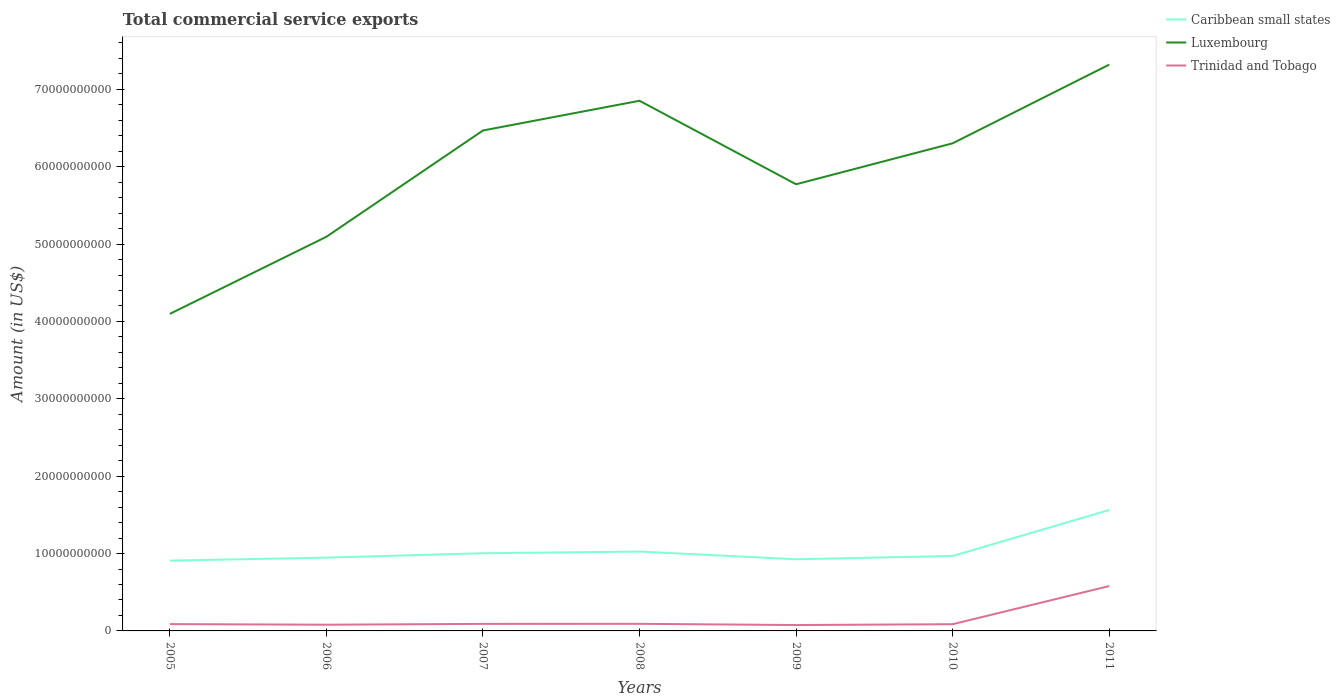How many different coloured lines are there?
Ensure brevity in your answer.  3. Is the number of lines equal to the number of legend labels?
Provide a succinct answer. Yes. Across all years, what is the maximum total commercial service exports in Luxembourg?
Your answer should be very brief. 4.10e+1. What is the total total commercial service exports in Luxembourg in the graph?
Give a very brief answer. -1.68e+1. What is the difference between the highest and the second highest total commercial service exports in Caribbean small states?
Your answer should be very brief. 6.55e+09. What is the difference between the highest and the lowest total commercial service exports in Luxembourg?
Your response must be concise. 4. How many lines are there?
Your answer should be very brief. 3. What is the difference between two consecutive major ticks on the Y-axis?
Provide a short and direct response. 1.00e+1. Are the values on the major ticks of Y-axis written in scientific E-notation?
Offer a terse response. No. How many legend labels are there?
Keep it short and to the point. 3. What is the title of the graph?
Keep it short and to the point. Total commercial service exports. What is the label or title of the X-axis?
Make the answer very short. Years. What is the label or title of the Y-axis?
Your answer should be compact. Amount (in US$). What is the Amount (in US$) in Caribbean small states in 2005?
Keep it short and to the point. 9.09e+09. What is the Amount (in US$) in Luxembourg in 2005?
Your response must be concise. 4.10e+1. What is the Amount (in US$) in Trinidad and Tobago in 2005?
Offer a terse response. 8.83e+08. What is the Amount (in US$) of Caribbean small states in 2006?
Make the answer very short. 9.47e+09. What is the Amount (in US$) of Luxembourg in 2006?
Give a very brief answer. 5.09e+1. What is the Amount (in US$) in Trinidad and Tobago in 2006?
Your answer should be compact. 8.02e+08. What is the Amount (in US$) in Caribbean small states in 2007?
Offer a terse response. 1.00e+1. What is the Amount (in US$) of Luxembourg in 2007?
Offer a very short reply. 6.47e+1. What is the Amount (in US$) of Trinidad and Tobago in 2007?
Make the answer very short. 9.10e+08. What is the Amount (in US$) of Caribbean small states in 2008?
Give a very brief answer. 1.03e+1. What is the Amount (in US$) in Luxembourg in 2008?
Provide a short and direct response. 6.85e+1. What is the Amount (in US$) in Trinidad and Tobago in 2008?
Offer a very short reply. 9.18e+08. What is the Amount (in US$) of Caribbean small states in 2009?
Offer a terse response. 9.26e+09. What is the Amount (in US$) of Luxembourg in 2009?
Provide a succinct answer. 5.77e+1. What is the Amount (in US$) in Trinidad and Tobago in 2009?
Your response must be concise. 7.58e+08. What is the Amount (in US$) of Caribbean small states in 2010?
Give a very brief answer. 9.69e+09. What is the Amount (in US$) in Luxembourg in 2010?
Ensure brevity in your answer.  6.30e+1. What is the Amount (in US$) in Trinidad and Tobago in 2010?
Give a very brief answer. 8.69e+08. What is the Amount (in US$) in Caribbean small states in 2011?
Provide a succinct answer. 1.56e+1. What is the Amount (in US$) in Luxembourg in 2011?
Offer a terse response. 7.32e+1. What is the Amount (in US$) of Trinidad and Tobago in 2011?
Your response must be concise. 5.80e+09. Across all years, what is the maximum Amount (in US$) in Caribbean small states?
Your answer should be very brief. 1.56e+1. Across all years, what is the maximum Amount (in US$) in Luxembourg?
Provide a short and direct response. 7.32e+1. Across all years, what is the maximum Amount (in US$) of Trinidad and Tobago?
Your response must be concise. 5.80e+09. Across all years, what is the minimum Amount (in US$) of Caribbean small states?
Provide a succinct answer. 9.09e+09. Across all years, what is the minimum Amount (in US$) of Luxembourg?
Your answer should be compact. 4.10e+1. Across all years, what is the minimum Amount (in US$) of Trinidad and Tobago?
Your response must be concise. 7.58e+08. What is the total Amount (in US$) in Caribbean small states in the graph?
Your answer should be very brief. 7.34e+1. What is the total Amount (in US$) in Luxembourg in the graph?
Your response must be concise. 4.19e+11. What is the total Amount (in US$) of Trinidad and Tobago in the graph?
Ensure brevity in your answer.  1.09e+1. What is the difference between the Amount (in US$) in Caribbean small states in 2005 and that in 2006?
Make the answer very short. -3.86e+08. What is the difference between the Amount (in US$) of Luxembourg in 2005 and that in 2006?
Provide a short and direct response. -9.97e+09. What is the difference between the Amount (in US$) of Trinidad and Tobago in 2005 and that in 2006?
Offer a terse response. 8.14e+07. What is the difference between the Amount (in US$) in Caribbean small states in 2005 and that in 2007?
Give a very brief answer. -9.54e+08. What is the difference between the Amount (in US$) of Luxembourg in 2005 and that in 2007?
Offer a very short reply. -2.37e+1. What is the difference between the Amount (in US$) in Trinidad and Tobago in 2005 and that in 2007?
Provide a succinct answer. -2.70e+07. What is the difference between the Amount (in US$) in Caribbean small states in 2005 and that in 2008?
Your response must be concise. -1.17e+09. What is the difference between the Amount (in US$) of Luxembourg in 2005 and that in 2008?
Give a very brief answer. -2.75e+1. What is the difference between the Amount (in US$) in Trinidad and Tobago in 2005 and that in 2008?
Provide a short and direct response. -3.54e+07. What is the difference between the Amount (in US$) in Caribbean small states in 2005 and that in 2009?
Make the answer very short. -1.77e+08. What is the difference between the Amount (in US$) in Luxembourg in 2005 and that in 2009?
Offer a very short reply. -1.68e+1. What is the difference between the Amount (in US$) in Trinidad and Tobago in 2005 and that in 2009?
Make the answer very short. 1.24e+08. What is the difference between the Amount (in US$) of Caribbean small states in 2005 and that in 2010?
Ensure brevity in your answer.  -6.00e+08. What is the difference between the Amount (in US$) in Luxembourg in 2005 and that in 2010?
Offer a very short reply. -2.20e+1. What is the difference between the Amount (in US$) of Trinidad and Tobago in 2005 and that in 2010?
Your response must be concise. 1.41e+07. What is the difference between the Amount (in US$) of Caribbean small states in 2005 and that in 2011?
Provide a succinct answer. -6.55e+09. What is the difference between the Amount (in US$) in Luxembourg in 2005 and that in 2011?
Ensure brevity in your answer.  -3.22e+1. What is the difference between the Amount (in US$) of Trinidad and Tobago in 2005 and that in 2011?
Your response must be concise. -4.92e+09. What is the difference between the Amount (in US$) of Caribbean small states in 2006 and that in 2007?
Your response must be concise. -5.68e+08. What is the difference between the Amount (in US$) of Luxembourg in 2006 and that in 2007?
Your answer should be very brief. -1.37e+1. What is the difference between the Amount (in US$) in Trinidad and Tobago in 2006 and that in 2007?
Provide a short and direct response. -1.08e+08. What is the difference between the Amount (in US$) of Caribbean small states in 2006 and that in 2008?
Provide a succinct answer. -7.85e+08. What is the difference between the Amount (in US$) in Luxembourg in 2006 and that in 2008?
Ensure brevity in your answer.  -1.76e+1. What is the difference between the Amount (in US$) of Trinidad and Tobago in 2006 and that in 2008?
Give a very brief answer. -1.17e+08. What is the difference between the Amount (in US$) in Caribbean small states in 2006 and that in 2009?
Keep it short and to the point. 2.09e+08. What is the difference between the Amount (in US$) of Luxembourg in 2006 and that in 2009?
Offer a very short reply. -6.79e+09. What is the difference between the Amount (in US$) of Trinidad and Tobago in 2006 and that in 2009?
Provide a succinct answer. 4.31e+07. What is the difference between the Amount (in US$) in Caribbean small states in 2006 and that in 2010?
Offer a terse response. -2.14e+08. What is the difference between the Amount (in US$) in Luxembourg in 2006 and that in 2010?
Provide a succinct answer. -1.21e+1. What is the difference between the Amount (in US$) in Trinidad and Tobago in 2006 and that in 2010?
Provide a short and direct response. -6.73e+07. What is the difference between the Amount (in US$) of Caribbean small states in 2006 and that in 2011?
Give a very brief answer. -6.16e+09. What is the difference between the Amount (in US$) of Luxembourg in 2006 and that in 2011?
Keep it short and to the point. -2.23e+1. What is the difference between the Amount (in US$) in Trinidad and Tobago in 2006 and that in 2011?
Offer a terse response. -5.00e+09. What is the difference between the Amount (in US$) of Caribbean small states in 2007 and that in 2008?
Provide a short and direct response. -2.17e+08. What is the difference between the Amount (in US$) of Luxembourg in 2007 and that in 2008?
Give a very brief answer. -3.84e+09. What is the difference between the Amount (in US$) in Trinidad and Tobago in 2007 and that in 2008?
Make the answer very short. -8.40e+06. What is the difference between the Amount (in US$) in Caribbean small states in 2007 and that in 2009?
Your answer should be compact. 7.77e+08. What is the difference between the Amount (in US$) of Luxembourg in 2007 and that in 2009?
Provide a short and direct response. 6.95e+09. What is the difference between the Amount (in US$) of Trinidad and Tobago in 2007 and that in 2009?
Keep it short and to the point. 1.52e+08. What is the difference between the Amount (in US$) of Caribbean small states in 2007 and that in 2010?
Offer a terse response. 3.54e+08. What is the difference between the Amount (in US$) in Luxembourg in 2007 and that in 2010?
Your answer should be compact. 1.66e+09. What is the difference between the Amount (in US$) of Trinidad and Tobago in 2007 and that in 2010?
Offer a terse response. 4.11e+07. What is the difference between the Amount (in US$) of Caribbean small states in 2007 and that in 2011?
Offer a terse response. -5.60e+09. What is the difference between the Amount (in US$) in Luxembourg in 2007 and that in 2011?
Keep it short and to the point. -8.52e+09. What is the difference between the Amount (in US$) of Trinidad and Tobago in 2007 and that in 2011?
Offer a very short reply. -4.89e+09. What is the difference between the Amount (in US$) in Caribbean small states in 2008 and that in 2009?
Your response must be concise. 9.94e+08. What is the difference between the Amount (in US$) in Luxembourg in 2008 and that in 2009?
Offer a very short reply. 1.08e+1. What is the difference between the Amount (in US$) in Trinidad and Tobago in 2008 and that in 2009?
Keep it short and to the point. 1.60e+08. What is the difference between the Amount (in US$) of Caribbean small states in 2008 and that in 2010?
Offer a very short reply. 5.71e+08. What is the difference between the Amount (in US$) of Luxembourg in 2008 and that in 2010?
Offer a very short reply. 5.50e+09. What is the difference between the Amount (in US$) of Trinidad and Tobago in 2008 and that in 2010?
Offer a terse response. 4.95e+07. What is the difference between the Amount (in US$) of Caribbean small states in 2008 and that in 2011?
Provide a succinct answer. -5.38e+09. What is the difference between the Amount (in US$) of Luxembourg in 2008 and that in 2011?
Your answer should be compact. -4.67e+09. What is the difference between the Amount (in US$) in Trinidad and Tobago in 2008 and that in 2011?
Provide a succinct answer. -4.88e+09. What is the difference between the Amount (in US$) of Caribbean small states in 2009 and that in 2010?
Provide a short and direct response. -4.23e+08. What is the difference between the Amount (in US$) of Luxembourg in 2009 and that in 2010?
Ensure brevity in your answer.  -5.29e+09. What is the difference between the Amount (in US$) in Trinidad and Tobago in 2009 and that in 2010?
Keep it short and to the point. -1.10e+08. What is the difference between the Amount (in US$) of Caribbean small states in 2009 and that in 2011?
Keep it short and to the point. -6.37e+09. What is the difference between the Amount (in US$) in Luxembourg in 2009 and that in 2011?
Your response must be concise. -1.55e+1. What is the difference between the Amount (in US$) in Trinidad and Tobago in 2009 and that in 2011?
Give a very brief answer. -5.04e+09. What is the difference between the Amount (in US$) of Caribbean small states in 2010 and that in 2011?
Give a very brief answer. -5.95e+09. What is the difference between the Amount (in US$) of Luxembourg in 2010 and that in 2011?
Keep it short and to the point. -1.02e+1. What is the difference between the Amount (in US$) of Trinidad and Tobago in 2010 and that in 2011?
Your answer should be very brief. -4.93e+09. What is the difference between the Amount (in US$) in Caribbean small states in 2005 and the Amount (in US$) in Luxembourg in 2006?
Ensure brevity in your answer.  -4.19e+1. What is the difference between the Amount (in US$) of Caribbean small states in 2005 and the Amount (in US$) of Trinidad and Tobago in 2006?
Keep it short and to the point. 8.29e+09. What is the difference between the Amount (in US$) in Luxembourg in 2005 and the Amount (in US$) in Trinidad and Tobago in 2006?
Make the answer very short. 4.02e+1. What is the difference between the Amount (in US$) of Caribbean small states in 2005 and the Amount (in US$) of Luxembourg in 2007?
Your response must be concise. -5.56e+1. What is the difference between the Amount (in US$) of Caribbean small states in 2005 and the Amount (in US$) of Trinidad and Tobago in 2007?
Give a very brief answer. 8.18e+09. What is the difference between the Amount (in US$) of Luxembourg in 2005 and the Amount (in US$) of Trinidad and Tobago in 2007?
Your answer should be very brief. 4.01e+1. What is the difference between the Amount (in US$) in Caribbean small states in 2005 and the Amount (in US$) in Luxembourg in 2008?
Your answer should be very brief. -5.94e+1. What is the difference between the Amount (in US$) of Caribbean small states in 2005 and the Amount (in US$) of Trinidad and Tobago in 2008?
Your answer should be compact. 8.17e+09. What is the difference between the Amount (in US$) in Luxembourg in 2005 and the Amount (in US$) in Trinidad and Tobago in 2008?
Your answer should be compact. 4.01e+1. What is the difference between the Amount (in US$) of Caribbean small states in 2005 and the Amount (in US$) of Luxembourg in 2009?
Give a very brief answer. -4.86e+1. What is the difference between the Amount (in US$) in Caribbean small states in 2005 and the Amount (in US$) in Trinidad and Tobago in 2009?
Ensure brevity in your answer.  8.33e+09. What is the difference between the Amount (in US$) in Luxembourg in 2005 and the Amount (in US$) in Trinidad and Tobago in 2009?
Offer a very short reply. 4.02e+1. What is the difference between the Amount (in US$) in Caribbean small states in 2005 and the Amount (in US$) in Luxembourg in 2010?
Your answer should be very brief. -5.39e+1. What is the difference between the Amount (in US$) of Caribbean small states in 2005 and the Amount (in US$) of Trinidad and Tobago in 2010?
Ensure brevity in your answer.  8.22e+09. What is the difference between the Amount (in US$) in Luxembourg in 2005 and the Amount (in US$) in Trinidad and Tobago in 2010?
Make the answer very short. 4.01e+1. What is the difference between the Amount (in US$) in Caribbean small states in 2005 and the Amount (in US$) in Luxembourg in 2011?
Provide a short and direct response. -6.41e+1. What is the difference between the Amount (in US$) in Caribbean small states in 2005 and the Amount (in US$) in Trinidad and Tobago in 2011?
Give a very brief answer. 3.29e+09. What is the difference between the Amount (in US$) of Luxembourg in 2005 and the Amount (in US$) of Trinidad and Tobago in 2011?
Your answer should be compact. 3.52e+1. What is the difference between the Amount (in US$) in Caribbean small states in 2006 and the Amount (in US$) in Luxembourg in 2007?
Offer a very short reply. -5.52e+1. What is the difference between the Amount (in US$) in Caribbean small states in 2006 and the Amount (in US$) in Trinidad and Tobago in 2007?
Your answer should be very brief. 8.56e+09. What is the difference between the Amount (in US$) in Luxembourg in 2006 and the Amount (in US$) in Trinidad and Tobago in 2007?
Give a very brief answer. 5.00e+1. What is the difference between the Amount (in US$) in Caribbean small states in 2006 and the Amount (in US$) in Luxembourg in 2008?
Provide a short and direct response. -5.91e+1. What is the difference between the Amount (in US$) of Caribbean small states in 2006 and the Amount (in US$) of Trinidad and Tobago in 2008?
Make the answer very short. 8.55e+09. What is the difference between the Amount (in US$) of Luxembourg in 2006 and the Amount (in US$) of Trinidad and Tobago in 2008?
Make the answer very short. 5.00e+1. What is the difference between the Amount (in US$) of Caribbean small states in 2006 and the Amount (in US$) of Luxembourg in 2009?
Give a very brief answer. -4.83e+1. What is the difference between the Amount (in US$) of Caribbean small states in 2006 and the Amount (in US$) of Trinidad and Tobago in 2009?
Your answer should be compact. 8.71e+09. What is the difference between the Amount (in US$) of Luxembourg in 2006 and the Amount (in US$) of Trinidad and Tobago in 2009?
Offer a very short reply. 5.02e+1. What is the difference between the Amount (in US$) of Caribbean small states in 2006 and the Amount (in US$) of Luxembourg in 2010?
Ensure brevity in your answer.  -5.36e+1. What is the difference between the Amount (in US$) of Caribbean small states in 2006 and the Amount (in US$) of Trinidad and Tobago in 2010?
Keep it short and to the point. 8.60e+09. What is the difference between the Amount (in US$) in Luxembourg in 2006 and the Amount (in US$) in Trinidad and Tobago in 2010?
Offer a terse response. 5.01e+1. What is the difference between the Amount (in US$) of Caribbean small states in 2006 and the Amount (in US$) of Luxembourg in 2011?
Give a very brief answer. -6.37e+1. What is the difference between the Amount (in US$) of Caribbean small states in 2006 and the Amount (in US$) of Trinidad and Tobago in 2011?
Make the answer very short. 3.67e+09. What is the difference between the Amount (in US$) in Luxembourg in 2006 and the Amount (in US$) in Trinidad and Tobago in 2011?
Provide a succinct answer. 4.51e+1. What is the difference between the Amount (in US$) in Caribbean small states in 2007 and the Amount (in US$) in Luxembourg in 2008?
Your response must be concise. -5.85e+1. What is the difference between the Amount (in US$) in Caribbean small states in 2007 and the Amount (in US$) in Trinidad and Tobago in 2008?
Your answer should be very brief. 9.12e+09. What is the difference between the Amount (in US$) in Luxembourg in 2007 and the Amount (in US$) in Trinidad and Tobago in 2008?
Make the answer very short. 6.38e+1. What is the difference between the Amount (in US$) of Caribbean small states in 2007 and the Amount (in US$) of Luxembourg in 2009?
Offer a very short reply. -4.77e+1. What is the difference between the Amount (in US$) of Caribbean small states in 2007 and the Amount (in US$) of Trinidad and Tobago in 2009?
Ensure brevity in your answer.  9.28e+09. What is the difference between the Amount (in US$) in Luxembourg in 2007 and the Amount (in US$) in Trinidad and Tobago in 2009?
Your response must be concise. 6.39e+1. What is the difference between the Amount (in US$) in Caribbean small states in 2007 and the Amount (in US$) in Luxembourg in 2010?
Your answer should be very brief. -5.30e+1. What is the difference between the Amount (in US$) of Caribbean small states in 2007 and the Amount (in US$) of Trinidad and Tobago in 2010?
Keep it short and to the point. 9.17e+09. What is the difference between the Amount (in US$) in Luxembourg in 2007 and the Amount (in US$) in Trinidad and Tobago in 2010?
Your answer should be compact. 6.38e+1. What is the difference between the Amount (in US$) of Caribbean small states in 2007 and the Amount (in US$) of Luxembourg in 2011?
Provide a succinct answer. -6.32e+1. What is the difference between the Amount (in US$) of Caribbean small states in 2007 and the Amount (in US$) of Trinidad and Tobago in 2011?
Offer a very short reply. 4.24e+09. What is the difference between the Amount (in US$) of Luxembourg in 2007 and the Amount (in US$) of Trinidad and Tobago in 2011?
Provide a short and direct response. 5.89e+1. What is the difference between the Amount (in US$) in Caribbean small states in 2008 and the Amount (in US$) in Luxembourg in 2009?
Give a very brief answer. -4.75e+1. What is the difference between the Amount (in US$) in Caribbean small states in 2008 and the Amount (in US$) in Trinidad and Tobago in 2009?
Provide a succinct answer. 9.50e+09. What is the difference between the Amount (in US$) in Luxembourg in 2008 and the Amount (in US$) in Trinidad and Tobago in 2009?
Keep it short and to the point. 6.78e+1. What is the difference between the Amount (in US$) of Caribbean small states in 2008 and the Amount (in US$) of Luxembourg in 2010?
Your answer should be compact. -5.28e+1. What is the difference between the Amount (in US$) in Caribbean small states in 2008 and the Amount (in US$) in Trinidad and Tobago in 2010?
Provide a succinct answer. 9.39e+09. What is the difference between the Amount (in US$) of Luxembourg in 2008 and the Amount (in US$) of Trinidad and Tobago in 2010?
Offer a terse response. 6.77e+1. What is the difference between the Amount (in US$) in Caribbean small states in 2008 and the Amount (in US$) in Luxembourg in 2011?
Your response must be concise. -6.29e+1. What is the difference between the Amount (in US$) of Caribbean small states in 2008 and the Amount (in US$) of Trinidad and Tobago in 2011?
Make the answer very short. 4.46e+09. What is the difference between the Amount (in US$) of Luxembourg in 2008 and the Amount (in US$) of Trinidad and Tobago in 2011?
Give a very brief answer. 6.27e+1. What is the difference between the Amount (in US$) in Caribbean small states in 2009 and the Amount (in US$) in Luxembourg in 2010?
Make the answer very short. -5.38e+1. What is the difference between the Amount (in US$) of Caribbean small states in 2009 and the Amount (in US$) of Trinidad and Tobago in 2010?
Your response must be concise. 8.39e+09. What is the difference between the Amount (in US$) in Luxembourg in 2009 and the Amount (in US$) in Trinidad and Tobago in 2010?
Ensure brevity in your answer.  5.69e+1. What is the difference between the Amount (in US$) in Caribbean small states in 2009 and the Amount (in US$) in Luxembourg in 2011?
Keep it short and to the point. -6.39e+1. What is the difference between the Amount (in US$) of Caribbean small states in 2009 and the Amount (in US$) of Trinidad and Tobago in 2011?
Ensure brevity in your answer.  3.47e+09. What is the difference between the Amount (in US$) of Luxembourg in 2009 and the Amount (in US$) of Trinidad and Tobago in 2011?
Your response must be concise. 5.19e+1. What is the difference between the Amount (in US$) of Caribbean small states in 2010 and the Amount (in US$) of Luxembourg in 2011?
Give a very brief answer. -6.35e+1. What is the difference between the Amount (in US$) in Caribbean small states in 2010 and the Amount (in US$) in Trinidad and Tobago in 2011?
Your answer should be compact. 3.89e+09. What is the difference between the Amount (in US$) in Luxembourg in 2010 and the Amount (in US$) in Trinidad and Tobago in 2011?
Offer a terse response. 5.72e+1. What is the average Amount (in US$) of Caribbean small states per year?
Offer a terse response. 1.05e+1. What is the average Amount (in US$) in Luxembourg per year?
Give a very brief answer. 5.99e+1. What is the average Amount (in US$) of Trinidad and Tobago per year?
Provide a short and direct response. 1.56e+09. In the year 2005, what is the difference between the Amount (in US$) of Caribbean small states and Amount (in US$) of Luxembourg?
Your answer should be compact. -3.19e+1. In the year 2005, what is the difference between the Amount (in US$) in Caribbean small states and Amount (in US$) in Trinidad and Tobago?
Make the answer very short. 8.20e+09. In the year 2005, what is the difference between the Amount (in US$) of Luxembourg and Amount (in US$) of Trinidad and Tobago?
Keep it short and to the point. 4.01e+1. In the year 2006, what is the difference between the Amount (in US$) in Caribbean small states and Amount (in US$) in Luxembourg?
Offer a terse response. -4.15e+1. In the year 2006, what is the difference between the Amount (in US$) of Caribbean small states and Amount (in US$) of Trinidad and Tobago?
Ensure brevity in your answer.  8.67e+09. In the year 2006, what is the difference between the Amount (in US$) of Luxembourg and Amount (in US$) of Trinidad and Tobago?
Offer a terse response. 5.01e+1. In the year 2007, what is the difference between the Amount (in US$) of Caribbean small states and Amount (in US$) of Luxembourg?
Your response must be concise. -5.46e+1. In the year 2007, what is the difference between the Amount (in US$) in Caribbean small states and Amount (in US$) in Trinidad and Tobago?
Your answer should be very brief. 9.13e+09. In the year 2007, what is the difference between the Amount (in US$) of Luxembourg and Amount (in US$) of Trinidad and Tobago?
Your answer should be very brief. 6.38e+1. In the year 2008, what is the difference between the Amount (in US$) in Caribbean small states and Amount (in US$) in Luxembourg?
Keep it short and to the point. -5.83e+1. In the year 2008, what is the difference between the Amount (in US$) in Caribbean small states and Amount (in US$) in Trinidad and Tobago?
Your response must be concise. 9.34e+09. In the year 2008, what is the difference between the Amount (in US$) of Luxembourg and Amount (in US$) of Trinidad and Tobago?
Provide a succinct answer. 6.76e+1. In the year 2009, what is the difference between the Amount (in US$) in Caribbean small states and Amount (in US$) in Luxembourg?
Ensure brevity in your answer.  -4.85e+1. In the year 2009, what is the difference between the Amount (in US$) of Caribbean small states and Amount (in US$) of Trinidad and Tobago?
Your answer should be compact. 8.51e+09. In the year 2009, what is the difference between the Amount (in US$) in Luxembourg and Amount (in US$) in Trinidad and Tobago?
Keep it short and to the point. 5.70e+1. In the year 2010, what is the difference between the Amount (in US$) of Caribbean small states and Amount (in US$) of Luxembourg?
Provide a short and direct response. -5.33e+1. In the year 2010, what is the difference between the Amount (in US$) of Caribbean small states and Amount (in US$) of Trinidad and Tobago?
Your response must be concise. 8.82e+09. In the year 2010, what is the difference between the Amount (in US$) in Luxembourg and Amount (in US$) in Trinidad and Tobago?
Provide a succinct answer. 6.22e+1. In the year 2011, what is the difference between the Amount (in US$) of Caribbean small states and Amount (in US$) of Luxembourg?
Give a very brief answer. -5.76e+1. In the year 2011, what is the difference between the Amount (in US$) in Caribbean small states and Amount (in US$) in Trinidad and Tobago?
Keep it short and to the point. 9.84e+09. In the year 2011, what is the difference between the Amount (in US$) in Luxembourg and Amount (in US$) in Trinidad and Tobago?
Ensure brevity in your answer.  6.74e+1. What is the ratio of the Amount (in US$) of Caribbean small states in 2005 to that in 2006?
Provide a short and direct response. 0.96. What is the ratio of the Amount (in US$) in Luxembourg in 2005 to that in 2006?
Offer a very short reply. 0.8. What is the ratio of the Amount (in US$) in Trinidad and Tobago in 2005 to that in 2006?
Offer a very short reply. 1.1. What is the ratio of the Amount (in US$) of Caribbean small states in 2005 to that in 2007?
Ensure brevity in your answer.  0.91. What is the ratio of the Amount (in US$) in Luxembourg in 2005 to that in 2007?
Your response must be concise. 0.63. What is the ratio of the Amount (in US$) in Trinidad and Tobago in 2005 to that in 2007?
Your response must be concise. 0.97. What is the ratio of the Amount (in US$) of Caribbean small states in 2005 to that in 2008?
Provide a succinct answer. 0.89. What is the ratio of the Amount (in US$) in Luxembourg in 2005 to that in 2008?
Offer a terse response. 0.6. What is the ratio of the Amount (in US$) in Trinidad and Tobago in 2005 to that in 2008?
Your answer should be very brief. 0.96. What is the ratio of the Amount (in US$) of Caribbean small states in 2005 to that in 2009?
Your answer should be compact. 0.98. What is the ratio of the Amount (in US$) in Luxembourg in 2005 to that in 2009?
Your answer should be very brief. 0.71. What is the ratio of the Amount (in US$) of Trinidad and Tobago in 2005 to that in 2009?
Ensure brevity in your answer.  1.16. What is the ratio of the Amount (in US$) of Caribbean small states in 2005 to that in 2010?
Offer a very short reply. 0.94. What is the ratio of the Amount (in US$) in Luxembourg in 2005 to that in 2010?
Your answer should be very brief. 0.65. What is the ratio of the Amount (in US$) in Trinidad and Tobago in 2005 to that in 2010?
Keep it short and to the point. 1.02. What is the ratio of the Amount (in US$) of Caribbean small states in 2005 to that in 2011?
Keep it short and to the point. 0.58. What is the ratio of the Amount (in US$) of Luxembourg in 2005 to that in 2011?
Your response must be concise. 0.56. What is the ratio of the Amount (in US$) in Trinidad and Tobago in 2005 to that in 2011?
Your answer should be compact. 0.15. What is the ratio of the Amount (in US$) in Caribbean small states in 2006 to that in 2007?
Keep it short and to the point. 0.94. What is the ratio of the Amount (in US$) of Luxembourg in 2006 to that in 2007?
Give a very brief answer. 0.79. What is the ratio of the Amount (in US$) in Trinidad and Tobago in 2006 to that in 2007?
Offer a terse response. 0.88. What is the ratio of the Amount (in US$) of Caribbean small states in 2006 to that in 2008?
Offer a very short reply. 0.92. What is the ratio of the Amount (in US$) in Luxembourg in 2006 to that in 2008?
Provide a succinct answer. 0.74. What is the ratio of the Amount (in US$) of Trinidad and Tobago in 2006 to that in 2008?
Your response must be concise. 0.87. What is the ratio of the Amount (in US$) of Caribbean small states in 2006 to that in 2009?
Ensure brevity in your answer.  1.02. What is the ratio of the Amount (in US$) of Luxembourg in 2006 to that in 2009?
Give a very brief answer. 0.88. What is the ratio of the Amount (in US$) in Trinidad and Tobago in 2006 to that in 2009?
Provide a succinct answer. 1.06. What is the ratio of the Amount (in US$) in Caribbean small states in 2006 to that in 2010?
Your answer should be very brief. 0.98. What is the ratio of the Amount (in US$) of Luxembourg in 2006 to that in 2010?
Keep it short and to the point. 0.81. What is the ratio of the Amount (in US$) in Trinidad and Tobago in 2006 to that in 2010?
Ensure brevity in your answer.  0.92. What is the ratio of the Amount (in US$) of Caribbean small states in 2006 to that in 2011?
Give a very brief answer. 0.61. What is the ratio of the Amount (in US$) in Luxembourg in 2006 to that in 2011?
Offer a very short reply. 0.7. What is the ratio of the Amount (in US$) of Trinidad and Tobago in 2006 to that in 2011?
Your answer should be compact. 0.14. What is the ratio of the Amount (in US$) in Caribbean small states in 2007 to that in 2008?
Give a very brief answer. 0.98. What is the ratio of the Amount (in US$) in Luxembourg in 2007 to that in 2008?
Give a very brief answer. 0.94. What is the ratio of the Amount (in US$) in Trinidad and Tobago in 2007 to that in 2008?
Keep it short and to the point. 0.99. What is the ratio of the Amount (in US$) of Caribbean small states in 2007 to that in 2009?
Your answer should be compact. 1.08. What is the ratio of the Amount (in US$) of Luxembourg in 2007 to that in 2009?
Offer a terse response. 1.12. What is the ratio of the Amount (in US$) of Trinidad and Tobago in 2007 to that in 2009?
Offer a very short reply. 1.2. What is the ratio of the Amount (in US$) of Caribbean small states in 2007 to that in 2010?
Provide a short and direct response. 1.04. What is the ratio of the Amount (in US$) in Luxembourg in 2007 to that in 2010?
Give a very brief answer. 1.03. What is the ratio of the Amount (in US$) of Trinidad and Tobago in 2007 to that in 2010?
Keep it short and to the point. 1.05. What is the ratio of the Amount (in US$) of Caribbean small states in 2007 to that in 2011?
Offer a terse response. 0.64. What is the ratio of the Amount (in US$) of Luxembourg in 2007 to that in 2011?
Keep it short and to the point. 0.88. What is the ratio of the Amount (in US$) of Trinidad and Tobago in 2007 to that in 2011?
Provide a short and direct response. 0.16. What is the ratio of the Amount (in US$) of Caribbean small states in 2008 to that in 2009?
Offer a very short reply. 1.11. What is the ratio of the Amount (in US$) in Luxembourg in 2008 to that in 2009?
Give a very brief answer. 1.19. What is the ratio of the Amount (in US$) of Trinidad and Tobago in 2008 to that in 2009?
Give a very brief answer. 1.21. What is the ratio of the Amount (in US$) of Caribbean small states in 2008 to that in 2010?
Your answer should be very brief. 1.06. What is the ratio of the Amount (in US$) of Luxembourg in 2008 to that in 2010?
Offer a terse response. 1.09. What is the ratio of the Amount (in US$) of Trinidad and Tobago in 2008 to that in 2010?
Offer a very short reply. 1.06. What is the ratio of the Amount (in US$) in Caribbean small states in 2008 to that in 2011?
Ensure brevity in your answer.  0.66. What is the ratio of the Amount (in US$) of Luxembourg in 2008 to that in 2011?
Provide a short and direct response. 0.94. What is the ratio of the Amount (in US$) of Trinidad and Tobago in 2008 to that in 2011?
Provide a succinct answer. 0.16. What is the ratio of the Amount (in US$) of Caribbean small states in 2009 to that in 2010?
Ensure brevity in your answer.  0.96. What is the ratio of the Amount (in US$) in Luxembourg in 2009 to that in 2010?
Your answer should be very brief. 0.92. What is the ratio of the Amount (in US$) in Trinidad and Tobago in 2009 to that in 2010?
Provide a succinct answer. 0.87. What is the ratio of the Amount (in US$) in Caribbean small states in 2009 to that in 2011?
Offer a very short reply. 0.59. What is the ratio of the Amount (in US$) in Luxembourg in 2009 to that in 2011?
Offer a very short reply. 0.79. What is the ratio of the Amount (in US$) of Trinidad and Tobago in 2009 to that in 2011?
Your answer should be very brief. 0.13. What is the ratio of the Amount (in US$) of Caribbean small states in 2010 to that in 2011?
Provide a succinct answer. 0.62. What is the ratio of the Amount (in US$) in Luxembourg in 2010 to that in 2011?
Provide a succinct answer. 0.86. What is the ratio of the Amount (in US$) in Trinidad and Tobago in 2010 to that in 2011?
Your answer should be compact. 0.15. What is the difference between the highest and the second highest Amount (in US$) of Caribbean small states?
Your response must be concise. 5.38e+09. What is the difference between the highest and the second highest Amount (in US$) of Luxembourg?
Your response must be concise. 4.67e+09. What is the difference between the highest and the second highest Amount (in US$) in Trinidad and Tobago?
Your answer should be very brief. 4.88e+09. What is the difference between the highest and the lowest Amount (in US$) of Caribbean small states?
Offer a very short reply. 6.55e+09. What is the difference between the highest and the lowest Amount (in US$) in Luxembourg?
Make the answer very short. 3.22e+1. What is the difference between the highest and the lowest Amount (in US$) in Trinidad and Tobago?
Provide a succinct answer. 5.04e+09. 